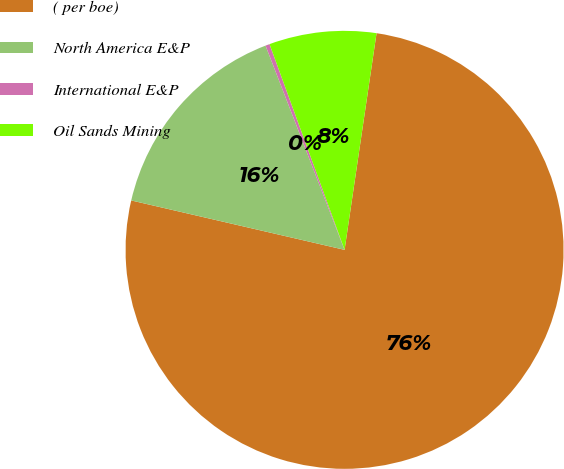<chart> <loc_0><loc_0><loc_500><loc_500><pie_chart><fcel>( per boe)<fcel>North America E&P<fcel>International E&P<fcel>Oil Sands Mining<nl><fcel>76.29%<fcel>15.5%<fcel>0.31%<fcel>7.9%<nl></chart> 